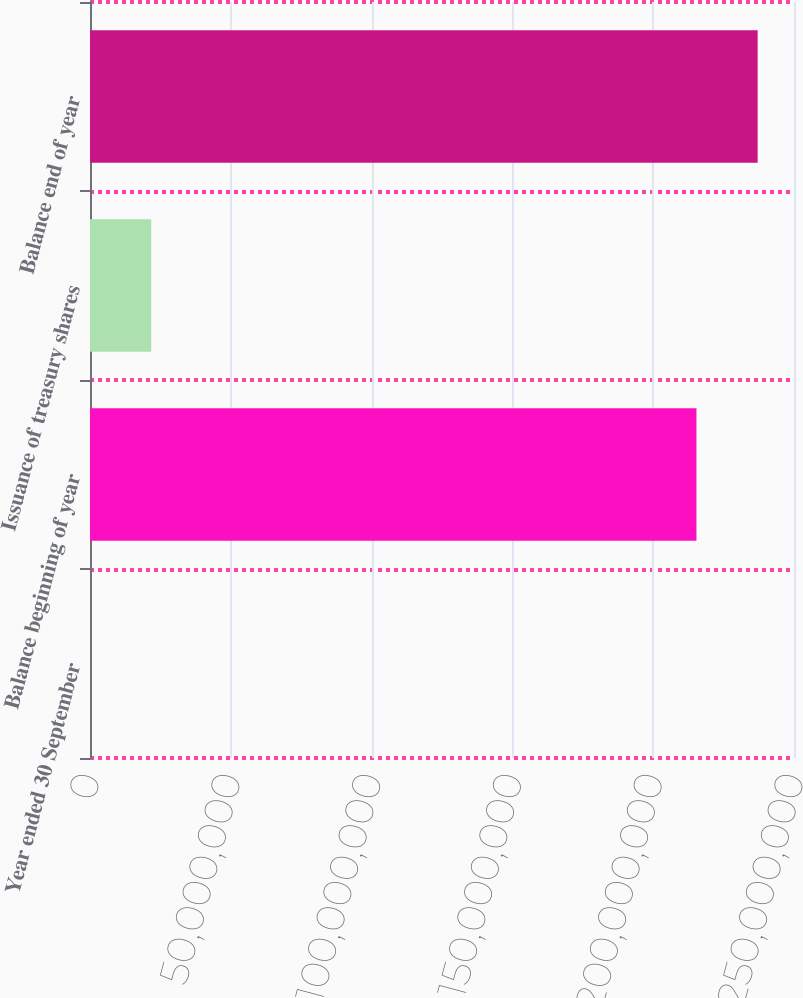<chart> <loc_0><loc_0><loc_500><loc_500><bar_chart><fcel>Year ended 30 September<fcel>Balance beginning of year<fcel>Issuance of treasury shares<fcel>Balance end of year<nl><fcel>2016<fcel>2.15359e+08<fcel>2.17369e+07<fcel>2.37094e+08<nl></chart> 